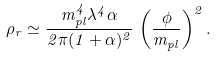Convert formula to latex. <formula><loc_0><loc_0><loc_500><loc_500>\rho _ { r } \simeq \frac { m _ { p l } ^ { 4 } \lambda ^ { 4 } \alpha } { 2 \pi ( 1 + \alpha ) ^ { 2 } } \, \left ( \frac { \phi } { m _ { p l } } \right ) ^ { 2 } .</formula> 